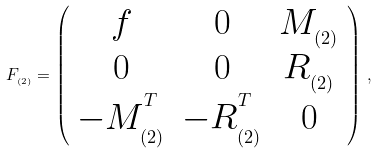Convert formula to latex. <formula><loc_0><loc_0><loc_500><loc_500>F _ { _ { ( 2 ) } } = \left ( \begin{array} { c c c } f & 0 & M _ { _ { ( 2 ) } } \\ 0 & 0 & R _ { _ { ( 2 ) } } \\ - M _ { _ { ( 2 ) } } ^ { ^ { T } } & - R _ { _ { ( 2 ) } } ^ { ^ { T } } & 0 \end{array} \right ) \, ,</formula> 